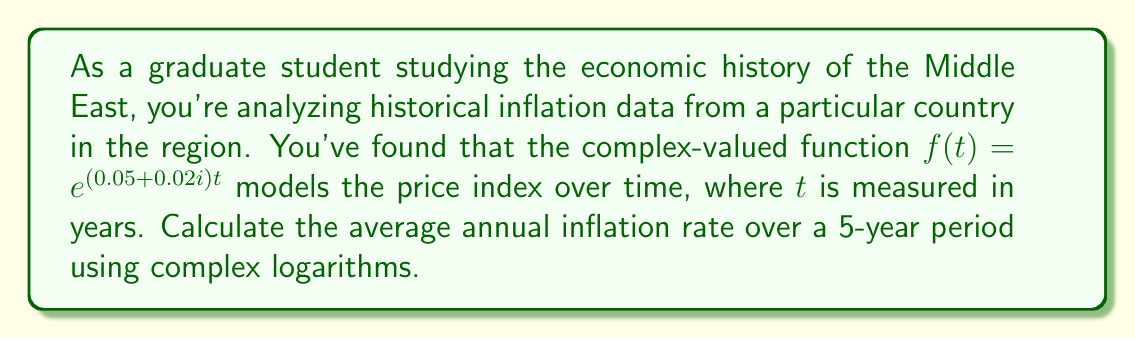Solve this math problem. To solve this problem, we'll follow these steps:

1) The general formula for calculating the average annual inflation rate $r$ over $n$ years is:

   $r = \left(\frac{P_n}{P_0}\right)^{\frac{1}{n}} - 1$

   where $P_n$ is the price index after $n$ years and $P_0$ is the initial price index.

2) In our case, $P_n = f(5)$ and $P_0 = f(0)$. Let's calculate these:

   $P_0 = f(0) = e^{(0.05 + 0.02i) \cdot 0} = e^0 = 1$

   $P_5 = f(5) = e^{(0.05 + 0.02i) \cdot 5} = e^{0.25 + 0.1i}$

3) Now we can plug these into our formula:

   $r = \left(\frac{e^{0.25 + 0.1i}}{1}\right)^{\frac{1}{5}} - 1$

4) Simplify:

   $r = (e^{0.25 + 0.1i})^{\frac{1}{5}} - 1$

5) To solve this, we can use the property of complex logarithms:

   $\ln(e^z) = z$ for any complex number $z$

   Taking the natural log of both sides:

   $\ln(r + 1) = \frac{1}{5}(0.25 + 0.1i)$

6) Solving for $r$:

   $r = e^{\frac{1}{5}(0.25 + 0.1i)} - 1$

7) Using Euler's formula, $e^{ix} = \cos x + i \sin x$, we can express this as:

   $r = e^{0.05}(\cos 0.02 + i \sin 0.02) - 1$

8) The real part of this complex number represents the actual inflation rate:

   $r \approx e^{0.05} \cos 0.02 - 1 \approx 0.0513$ or about 5.13%
Answer: The average annual inflation rate over the 5-year period is approximately 5.13%. 